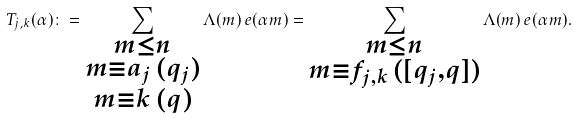<formula> <loc_0><loc_0><loc_500><loc_500>T _ { j , k } ( \alpha ) \colon = \sum _ { \substack { m \leq n \\ m \equiv a _ { j } \, ( q _ { j } ) \\ m \equiv k \, ( q ) } } \Lambda ( m ) \, e ( \alpha m ) = \sum _ { \substack { m \leq n \\ m \equiv f _ { j , k } \, ( [ q _ { j } , q ] ) } } \Lambda ( m ) \, e ( \alpha m ) .</formula> 